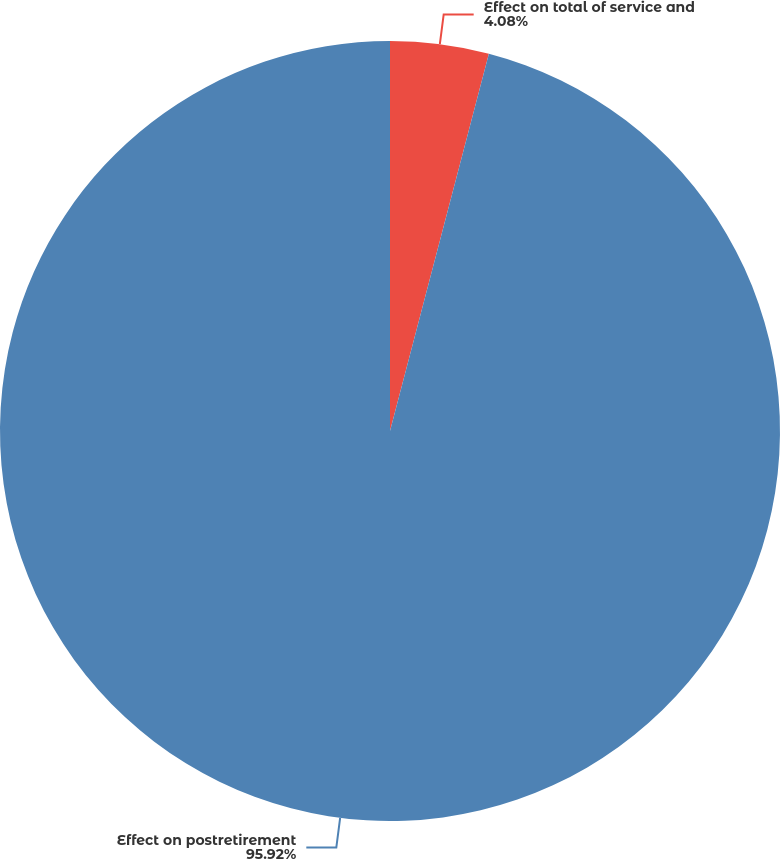<chart> <loc_0><loc_0><loc_500><loc_500><pie_chart><fcel>Effect on total of service and<fcel>Effect on postretirement<nl><fcel>4.08%<fcel>95.92%<nl></chart> 